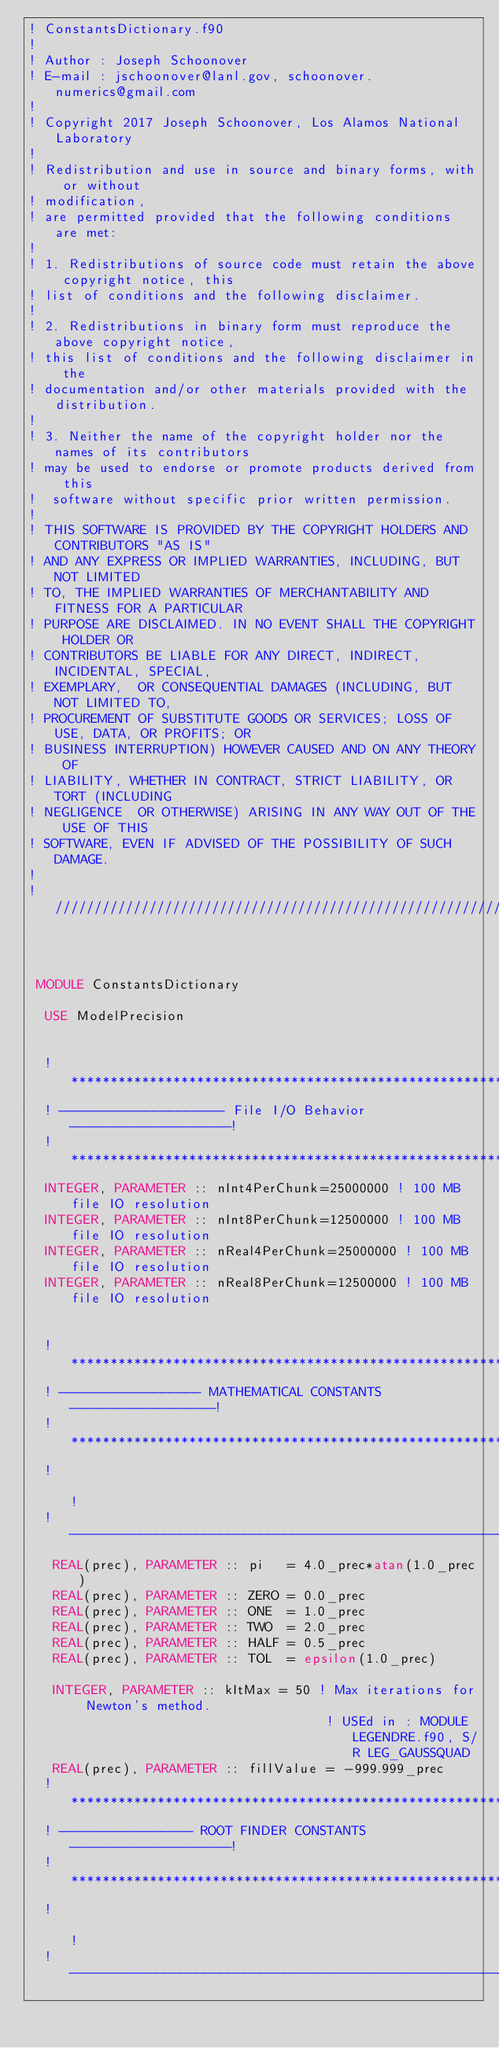<code> <loc_0><loc_0><loc_500><loc_500><_FORTRAN_>! ConstantsDictionary.f90
!
! Author : Joseph Schoonover
! E-mail : jschoonover@lanl.gov, schoonover.numerics@gmail.com
!
! Copyright 2017 Joseph Schoonover, Los Alamos National Laboratory
! 
! Redistribution and use in source and binary forms, with or without
! modification,
! are permitted provided that the following conditions are met:
! 
! 1. Redistributions of source code must retain the above copyright notice, this
! list of conditions and the following disclaimer.
! 
! 2. Redistributions in binary form must reproduce the above copyright notice,
! this list of conditions and the following disclaimer in the 
! documentation and/or other materials provided with the distribution.
! 
! 3. Neither the name of the copyright holder nor the names of its contributors
! may be used to endorse or promote products derived from this 
!  software without specific prior written permission.
! 
! THIS SOFTWARE IS PROVIDED BY THE COPYRIGHT HOLDERS AND CONTRIBUTORS "AS IS"
! AND ANY EXPRESS OR IMPLIED WARRANTIES, INCLUDING, BUT NOT LIMITED 
! TO, THE IMPLIED WARRANTIES OF MERCHANTABILITY AND FITNESS FOR A PARTICULAR
! PURPOSE ARE DISCLAIMED. IN NO EVENT SHALL THE COPYRIGHT HOLDER OR 
! CONTRIBUTORS BE LIABLE FOR ANY DIRECT, INDIRECT, INCIDENTAL, SPECIAL,
! EXEMPLARY,  OR CONSEQUENTIAL DAMAGES (INCLUDING, BUT NOT LIMITED TO, 
! PROCUREMENT OF SUBSTITUTE GOODS OR SERVICES; LOSS OF USE, DATA, OR PROFITS; OR
! BUSINESS INTERRUPTION) HOWEVER CAUSED AND ON ANY THEORY OF 
! LIABILITY, WHETHER IN CONTRACT, STRICT LIABILITY, OR TORT (INCLUDING
! NEGLIGENCE  OR OTHERWISE) ARISING IN ANY WAY OUT OF THE USE OF THIS 
! SOFTWARE, EVEN IF ADVISED OF THE POSSIBILITY OF SUCH DAMAGE.
!
! ////////////////////////////////////////////////////////////////////////////////////////////////
 
 

 MODULE ConstantsDictionary

  USE ModelPrecision

  
  !*************************************************************!
  ! --------------------- File I/O Behavior --------------------!
  ! ************************************************************!
  INTEGER, PARAMETER :: nInt4PerChunk=25000000 ! 100 MB file IO resolution
  INTEGER, PARAMETER :: nInt8PerChunk=12500000 ! 100 MB file IO resolution
  INTEGER, PARAMETER :: nReal4PerChunk=25000000 ! 100 MB file IO resolution
  INTEGER, PARAMETER :: nReal8PerChunk=12500000 ! 100 MB file IO resolution


  !*************************************************************!
  ! ------------------ MATHEMATICAL CONSTANTS ------------------!
  ! ************************************************************!
  !                                                             !
  ! ------------------------------------------------------------!
   REAL(prec), PARAMETER :: pi   = 4.0_prec*atan(1.0_prec)
   REAL(prec), PARAMETER :: ZERO = 0.0_prec
   REAL(prec), PARAMETER :: ONE  = 1.0_prec
   REAL(prec), PARAMETER :: TWO  = 2.0_prec
   REAL(prec), PARAMETER :: HALF = 0.5_prec
   REAL(prec), PARAMETER :: TOL  = epsilon(1.0_prec)

   INTEGER, PARAMETER :: kItMax = 50 ! Max iterations for Newton's method.
                                      ! USEd in : MODULE LEGENDRE.f90, S/R LEG_GAUSSQUAD
   REAL(prec), PARAMETER :: fillValue = -999.999_prec
  !*************************************************************!
  ! ----------------- ROOT FINDER CONSTANTS --------------------!
  ! ************************************************************!
  !                                                             !
  ! ------------------------------------------------------------!</code> 